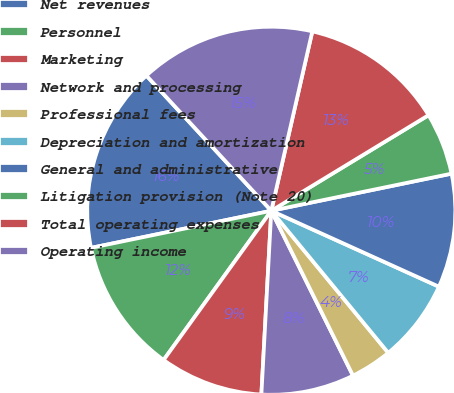<chart> <loc_0><loc_0><loc_500><loc_500><pie_chart><fcel>Net revenues<fcel>Personnel<fcel>Marketing<fcel>Network and processing<fcel>Professional fees<fcel>Depreciation and amortization<fcel>General and administrative<fcel>Litigation provision (Note 20)<fcel>Total operating expenses<fcel>Operating income<nl><fcel>16.36%<fcel>11.82%<fcel>9.09%<fcel>8.18%<fcel>3.64%<fcel>7.27%<fcel>10.0%<fcel>5.46%<fcel>12.73%<fcel>15.45%<nl></chart> 